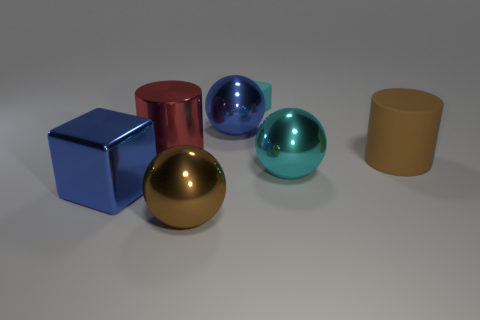Add 1 tiny gray cubes. How many objects exist? 8 Subtract all cylinders. How many objects are left? 5 Subtract 0 green spheres. How many objects are left? 7 Subtract all tiny blocks. Subtract all tiny cyan rubber blocks. How many objects are left? 5 Add 4 large cyan balls. How many large cyan balls are left? 5 Add 1 tiny gray matte cylinders. How many tiny gray matte cylinders exist? 1 